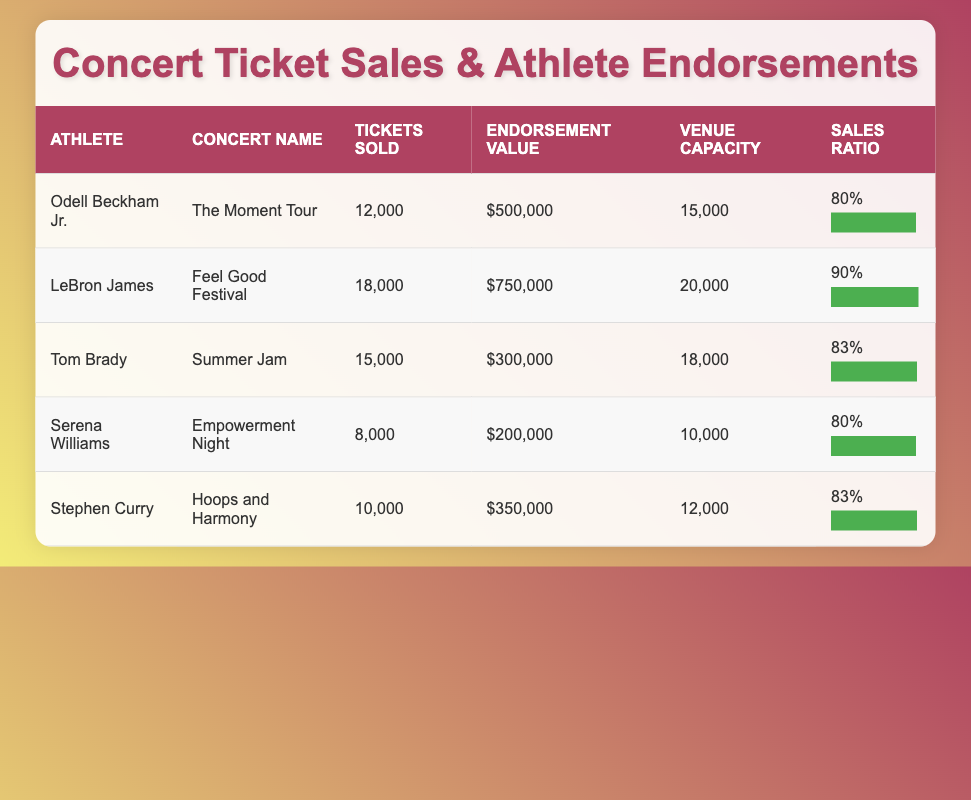What concert had the highest number of tickets sold? From the table, I compare the "Tickets Sold" values for each concert. LeBron James's "Feel Good Festival" has the highest number at 18,000 tickets sold.
Answer: 18,000 Which athlete has the lowest endorsement value? I look through the "Endorsement Value" column to find the lowest value. Serena Williams has an endorsement value of $200,000, which is the smallest amount compared to the others.
Answer: $200,000 What is the average ticket sales ratio across all concerts? First, I extract the sales ratios: 80%, 90%, 83%, 80%, 83%. I sum these values (80 + 90 + 83 + 80 + 83 = 416) and divide by 5 to find the average: 416 / 5 = 83.2%.
Answer: 83.2% Did Odell Beckham Jr.'s "The Moment Tour" sell more tickets than Serena Williams' "Empowerment Night"? I compare the "Tickets Sold" values: Odell sold 12,000 tickets while Serena sold 8,000 tickets. Since 12,000 is greater than 8,000, Odell sold more tickets.
Answer: Yes What is the difference in endorsement value between Tom Brady and Stephen Curry? I look at the endorsement values: Tom Brady's value is $300,000, and Stephen Curry's is $350,000. I calculate the difference: $350,000 - $300,000 = $50,000.
Answer: $50,000 